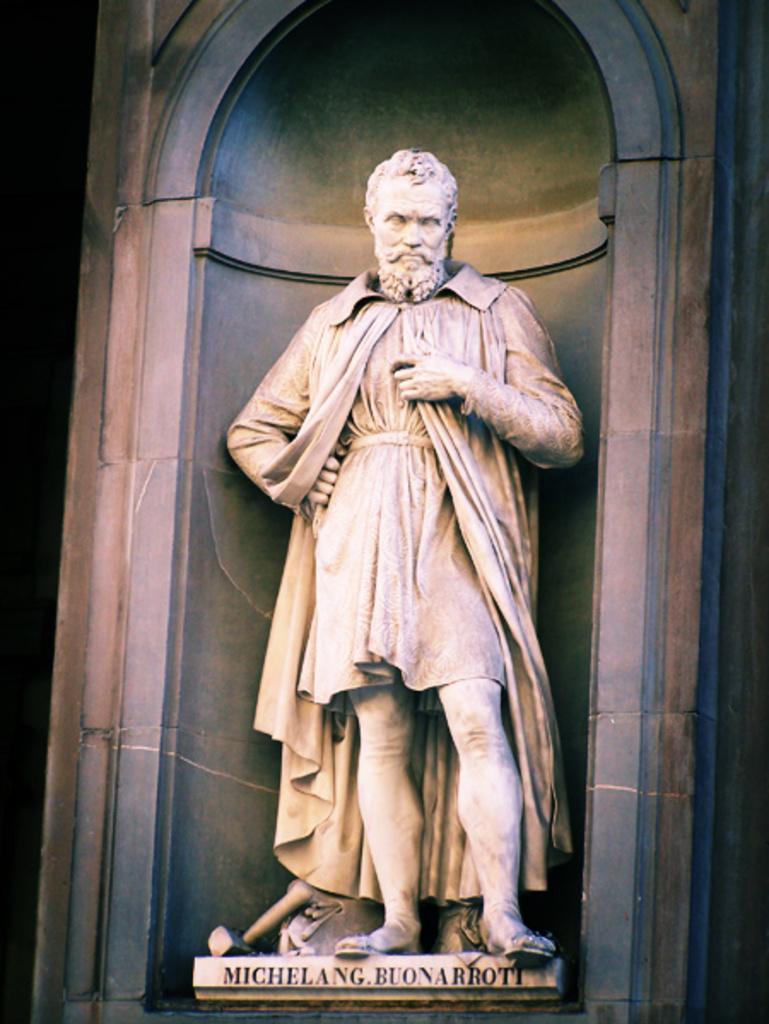Describe this image in one or two sentences. In this image there is one statue of one person is in middle of this image and there is a wall in the background and there is a text written at bottom of this image. 